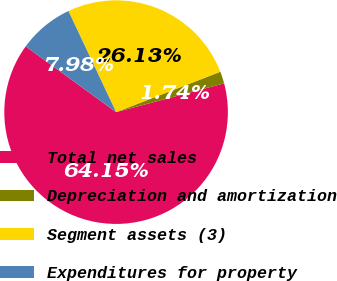Convert chart. <chart><loc_0><loc_0><loc_500><loc_500><pie_chart><fcel>Total net sales<fcel>Depreciation and amortization<fcel>Segment assets (3)<fcel>Expenditures for property<nl><fcel>64.15%<fcel>1.74%<fcel>26.13%<fcel>7.98%<nl></chart> 